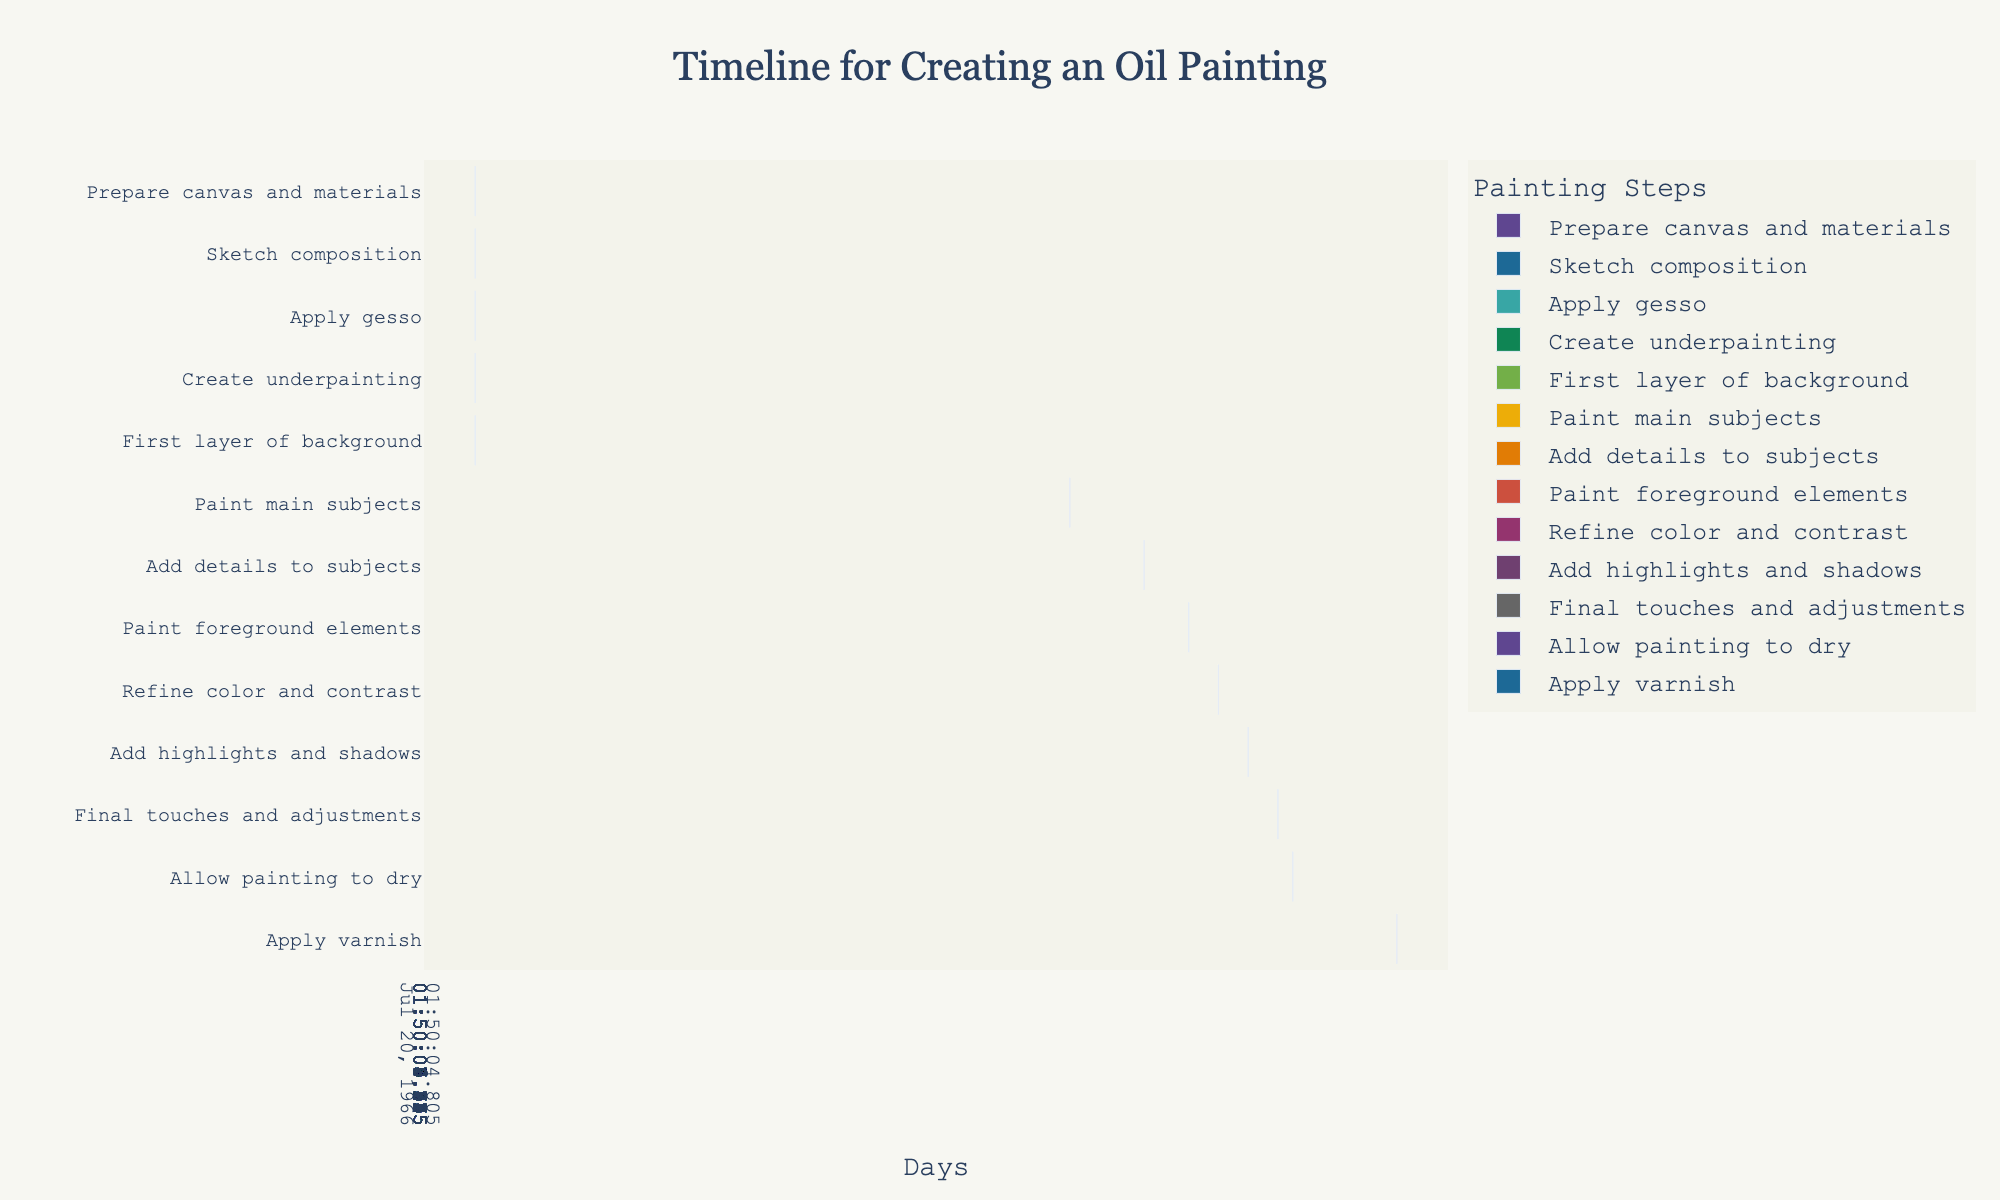How many tasks are in the timeline? Count the number of rows in the Gantt chart, each representing a task.
Answer: 13 What is the first task, and on which day does it start? Look at the first row in the Gantt chart to find the task name and its start day.
Answer: Prepare canvas and materials, Day 1 On which day does the task "Paint main subjects" start, and what is its duration? Find the "Paint main subjects" task in the chart and check the start day and duration listed for it.
Answer: Day 10, 5 days What tasks are overlapping between Day 20 and Day 21? Identify all tasks whose start or end days include or span across Day 20 and Day 21.
Answer: Refine color and contrast, Add details to subjects How many tasks are completed before Day 10? Identify and count the tasks whose end days are less than Day 10.
Answer: 4 Which task has the longest duration, and how many days does it last? Compare the durations of all tasks and identify the one with the greatest value.
Answer: Allow painting to dry, 7 days Calculate the total number of days from the start to apply gesso until the start to add details to subjects? Determine the start day of "Apply gesso" (Day 4) and the start day of "Add details to subjects" (Day 15). Calculate the difference.
Answer: 11 days Which tasks occur after "Apply varnish" is completed? Look for tasks that start after the end day of "Apply varnish" (Day 33).
Answer: None Between "Create underpainting" and "Paint main subjects", which task finishes later? Compare the end days of "Create underpainting" (Day 8) and "Paint main subjects" (Day 15).
Answer: Paint main subjects What are the final two steps in the timeline, and when do they start? Identify the last two rows in the Gantt chart and check the start day for each.
Answer: Allow painting to dry, Apply varnish, Day 25, Day 32 